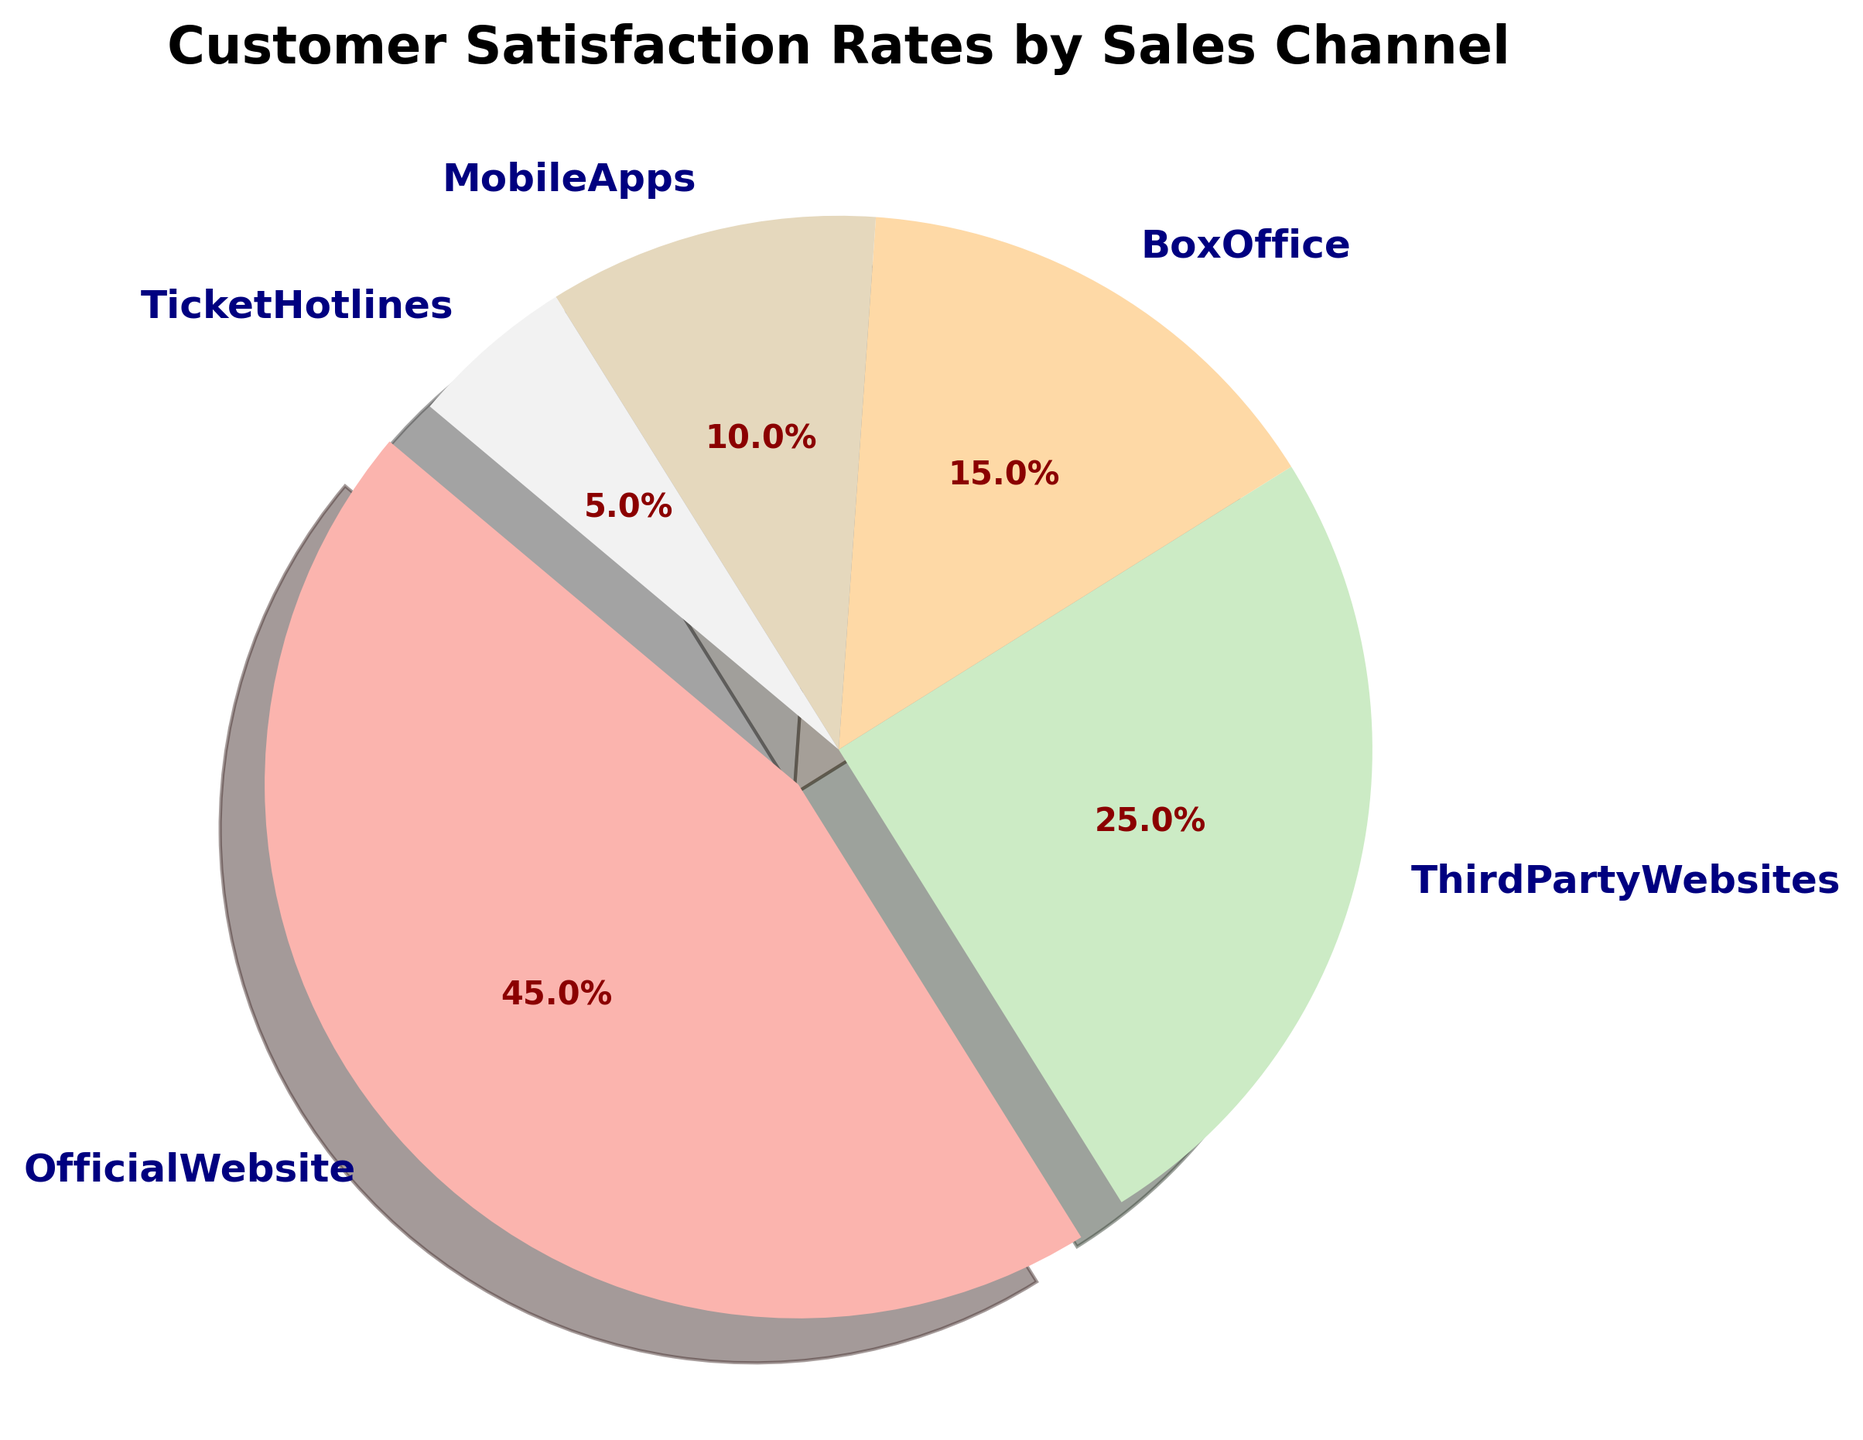what percentage of customer satisfaction comes from the OfficialWebsite? The pie chart has a section labeled 'OfficialWebsite' with an autopct value of 45.0%. This represents the customer satisfaction rate for the OfficialWebsite channel.
Answer: 45% How does the customer satisfaction rate of ThirdPartyWebsites compare to that of MobileApps? According to the pie chart, ThirdPartyWebsites has a satisfaction rate of 25% while MobileApps has 10%. By visual comparison, ThirdPartyWebsites has a higher satisfaction rate.
Answer: ThirdPartyWebsites > MobileApps What is the combined satisfaction rate of MobileApps and TicketHotlines? The chart shows that MobileApps have 10% and TicketHotlines have 5%. Adding these rates together: 10% + 5% = 15%.
Answer: 15% Out of all the channels, which one has the lowest customer satisfaction rate? The smallest segment in the pie chart belongs to 'TicketHotlines' with a satisfaction rate of 5%.
Answer: TicketHotlines Is the satisfaction rate for the OfficialWebsite more than double that of BoxOffice? The OfficialWebsite has a satisfaction rate of 45% and BoxOffice has 15%. To check if 45% is more than double 15%, we compute 15% * 2 = 30%. Since 45% > 30%, OfficialWebsite is indeed more than double.
Answer: Yes Which channel has a customer satisfaction rate closest to one-quarter of the total satisfaction rates? One-quarter of the total pie chart (100%) is 25%. The segment labeled 'ThirdPartyWebsites' has exactly 25% satisfaction rate.
Answer: ThirdPartyWebsites What is the visual highlight in the pie chart? The pie chart uses an 'explode' feature to highlight one section. The 'OfficialWebsite' segment is visually separated from the rest, indicating it as the most prominent.
Answer: OfficialWebsite How much greater is the satisfaction rate from the OfficialWebsite compared to BoxOffice? The OfficialWebsite has a satisfaction rate of 45% and BoxOffice has 15%. The difference is computed as 45% - 15% = 30%.
Answer: 30% Which channels make up more than 50% of customer satisfaction when combined? The segments in the pie chart for OfficialWebsite (45%) and ThirdPartyWebsites (25%) add up to 70%. This combined percentage is greater than 50%.
Answer: OfficialWebsite and ThirdPartyWebsites 